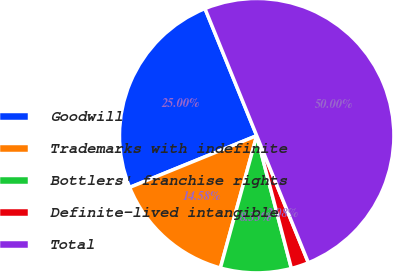Convert chart. <chart><loc_0><loc_0><loc_500><loc_500><pie_chart><fcel>Goodwill<fcel>Trademarks with indefinite<fcel>Bottlers' franchise rights<fcel>Definite-lived intangible<fcel>Total<nl><fcel>25.0%<fcel>14.58%<fcel>8.33%<fcel>2.08%<fcel>50.0%<nl></chart> 